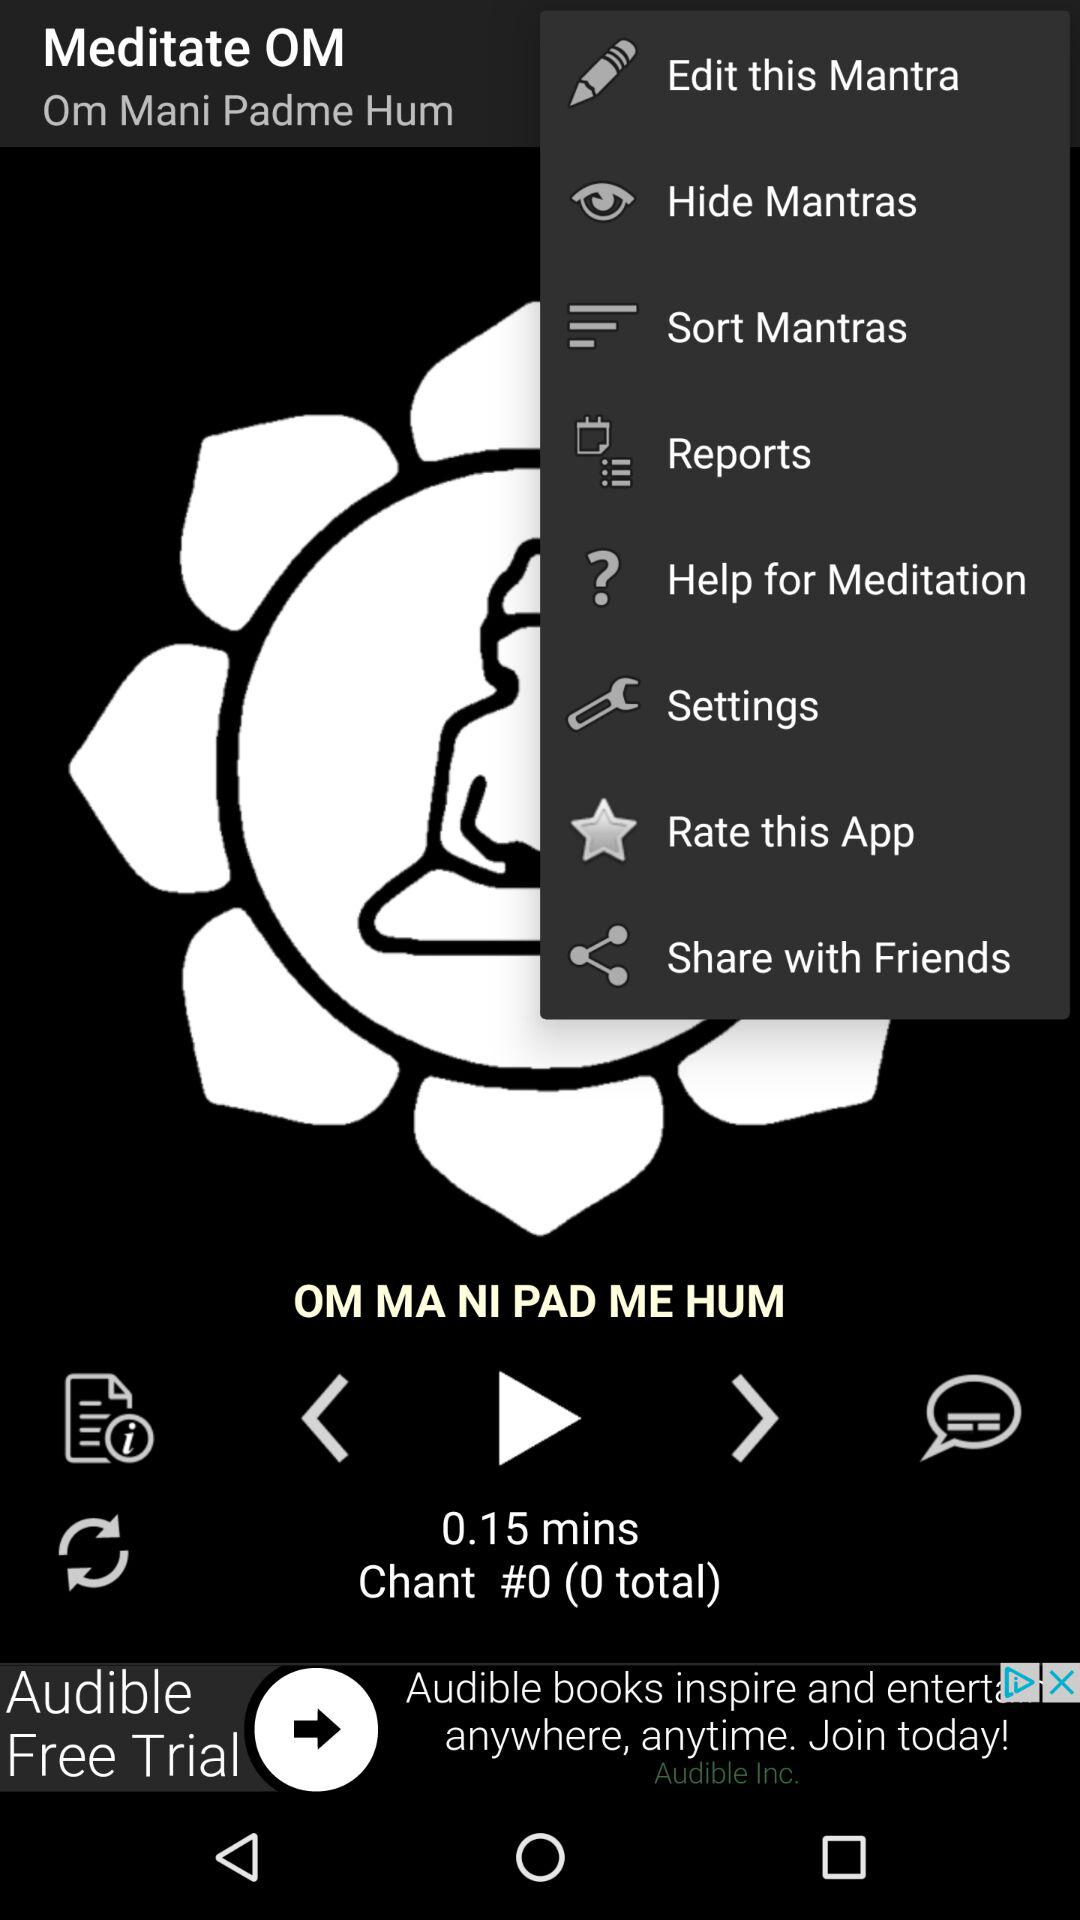How many minutes is the shortest chant?
Answer the question using a single word or phrase. 0.15 